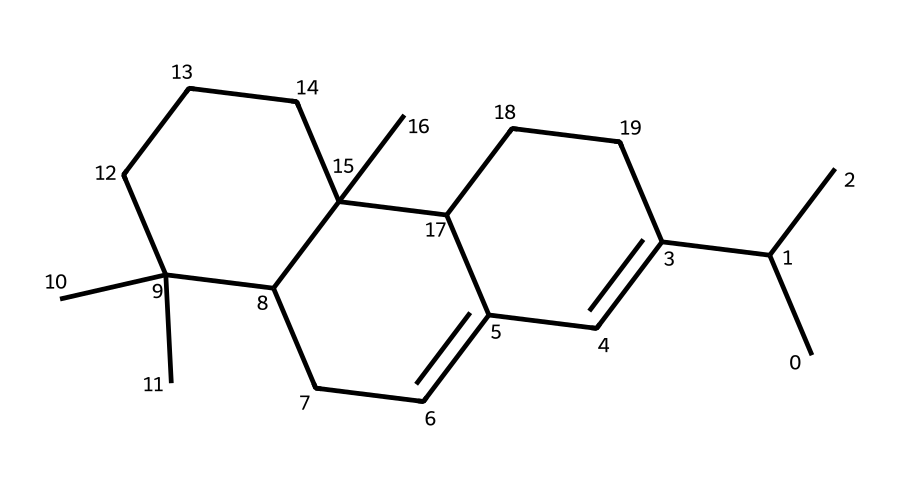how many carbon atoms are present in the structure? To find the number of carbon atoms, we need to count each carbon symbol (C) in the SMILES string. In this structure, there are 30 carbon atoms visible.
Answer: 30 what is the degree of unsaturation in this compound? The degree of unsaturation can be calculated using the formula: Degree of Unsaturation = (2C + 2 + N - H - X)/2. Here, C = 30, H = 50 (based on typical bonding patterns for carbons), N = 0, and X = 0. Thus: (2*30 + 2 - 50)/2 = 5. Therefore, the degree of unsaturation is 5.
Answer: 5 what type of functional groups are present in the structure? The structure primarily features cycloalkane rings with no specific functional groups, indicating that it is likely composed of aliphatic hydrocarbons.
Answer: cycloalkanes is this compound likely to be a solid or a liquid at room temperature? Due to the high number of carbon atoms and the presence of multiple rings, this compound is likely to have a high melting point and be a solid at room temperature.
Answer: solid which part of this structure contributes to its adhesive properties? The complex polycyclic structure and branching in the compound enhance intermolecular forces, which are crucial for adhesive properties, particularly through van der Waals forces and possibly hydrogen bonding, contributing to stickiness.
Answer: complex polycyclic structure how many ring structures are present in the compound? Upon analyzing the SMILES for cyclic features, we can identify multiple interconnected rings. There seems to be 3 distinct cyclic structures based on the connectivity in the structure.
Answer: 3 